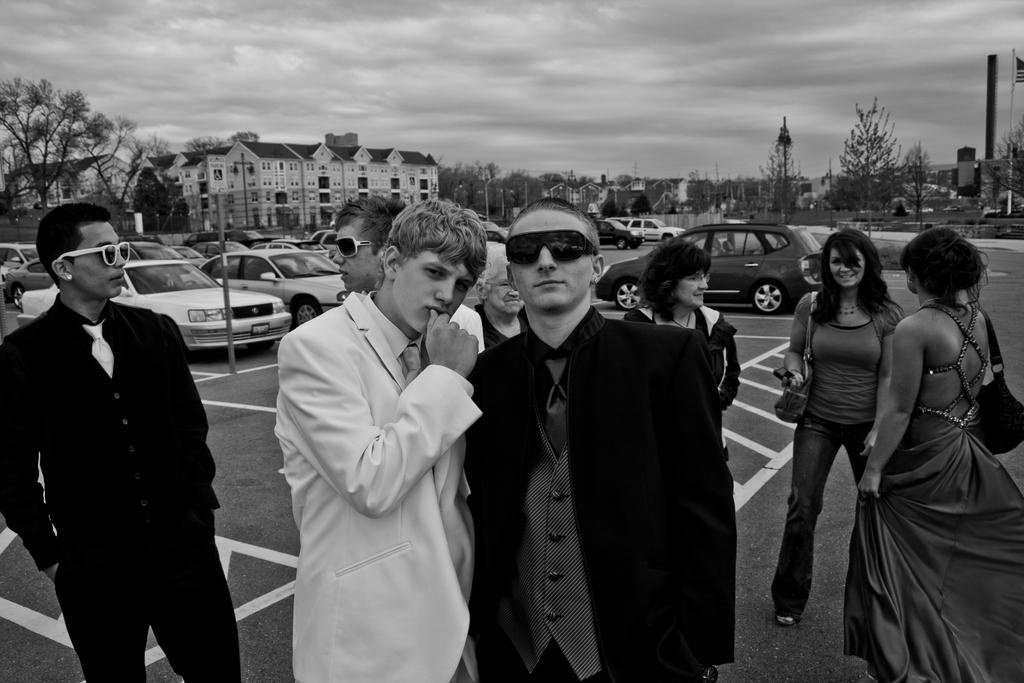How many people are visible in the image? There are many people in the image. What else can be seen in the image besides people? There are many cars, trees, buildings, street lights, a pole, and a flag on the pole. What is the condition of the sky in the image? The sky is cloudy in the image. How many ladybugs are crawling on the cars in the image? There are no ladybugs visible in the image; it features people, cars, trees, buildings, street lights, a pole, and a flag on the pole. What type of breakfast is being served in the image? There is no breakfast present in the image; it focuses on people, cars, trees, buildings, street lights, a pole, and a flag on the pole. 